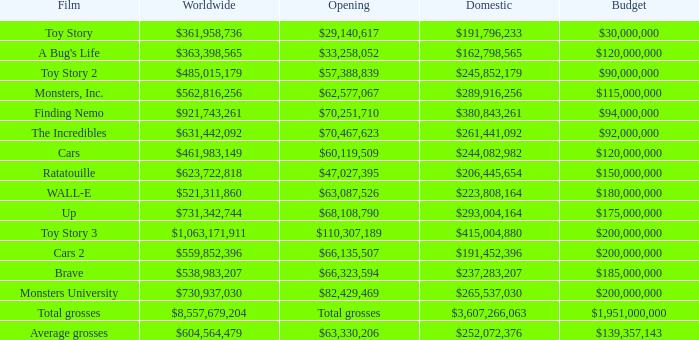WHAT IS THE OPENING WITH A WORLDWIDE NUMBER OF $559,852,396? $66,135,507. Can you parse all the data within this table? {'header': ['Film', 'Worldwide', 'Opening', 'Domestic', 'Budget'], 'rows': [['Toy Story', '$361,958,736', '$29,140,617', '$191,796,233', '$30,000,000'], ["A Bug's Life", '$363,398,565', '$33,258,052', '$162,798,565', '$120,000,000'], ['Toy Story 2', '$485,015,179', '$57,388,839', '$245,852,179', '$90,000,000'], ['Monsters, Inc.', '$562,816,256', '$62,577,067', '$289,916,256', '$115,000,000'], ['Finding Nemo', '$921,743,261', '$70,251,710', '$380,843,261', '$94,000,000'], ['The Incredibles', '$631,442,092', '$70,467,623', '$261,441,092', '$92,000,000'], ['Cars', '$461,983,149', '$60,119,509', '$244,082,982', '$120,000,000'], ['Ratatouille', '$623,722,818', '$47,027,395', '$206,445,654', '$150,000,000'], ['WALL-E', '$521,311,860', '$63,087,526', '$223,808,164', '$180,000,000'], ['Up', '$731,342,744', '$68,108,790', '$293,004,164', '$175,000,000'], ['Toy Story 3', '$1,063,171,911', '$110,307,189', '$415,004,880', '$200,000,000'], ['Cars 2', '$559,852,396', '$66,135,507', '$191,452,396', '$200,000,000'], ['Brave', '$538,983,207', '$66,323,594', '$237,283,207', '$185,000,000'], ['Monsters University', '$730,937,030', '$82,429,469', '$265,537,030', '$200,000,000'], ['Total grosses', '$8,557,679,204', 'Total grosses', '$3,607,266,063', '$1,951,000,000'], ['Average grosses', '$604,564,479', '$63,330,206', '$252,072,376', '$139,357,143']]} 